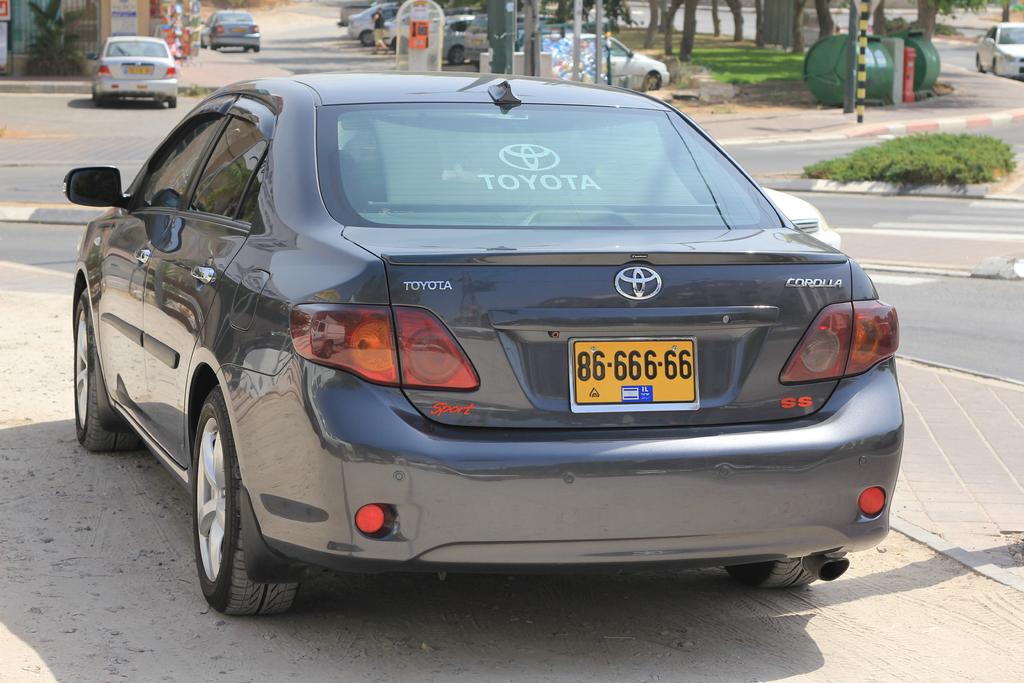What brand car is this?
Your answer should be compact. Toyota. 